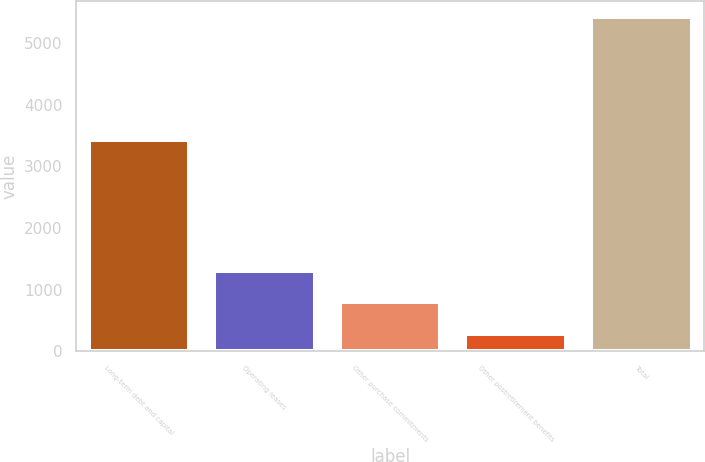Convert chart. <chart><loc_0><loc_0><loc_500><loc_500><bar_chart><fcel>Long-term debt and capital<fcel>Operating leases<fcel>Other purchase commitments<fcel>Other postretirement benefits<fcel>Total<nl><fcel>3423<fcel>1311<fcel>798<fcel>285<fcel>5415<nl></chart> 